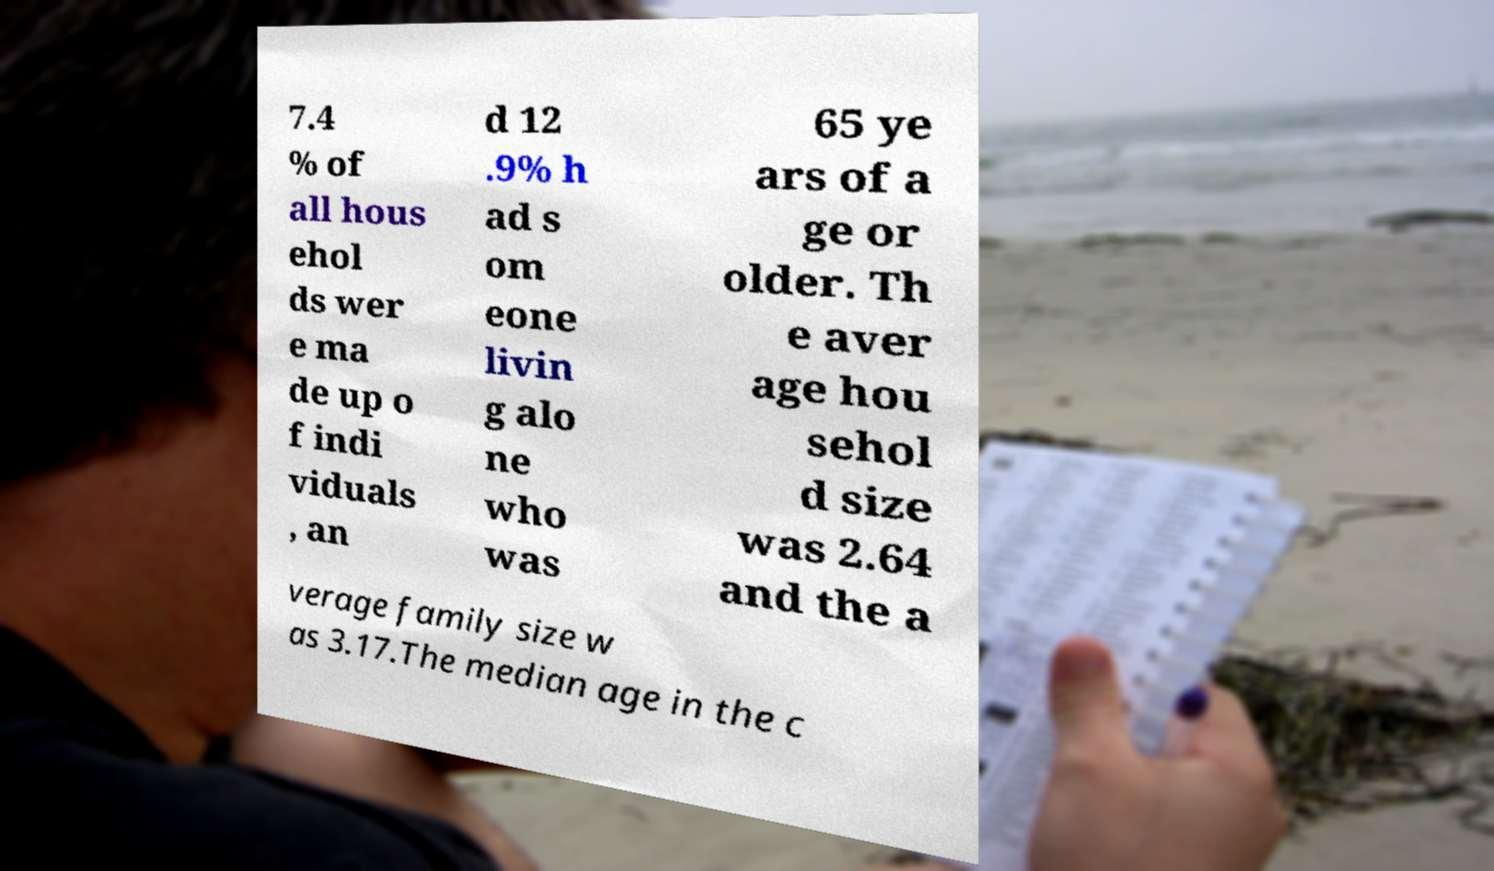I need the written content from this picture converted into text. Can you do that? 7.4 % of all hous ehol ds wer e ma de up o f indi viduals , an d 12 .9% h ad s om eone livin g alo ne who was 65 ye ars of a ge or older. Th e aver age hou sehol d size was 2.64 and the a verage family size w as 3.17.The median age in the c 